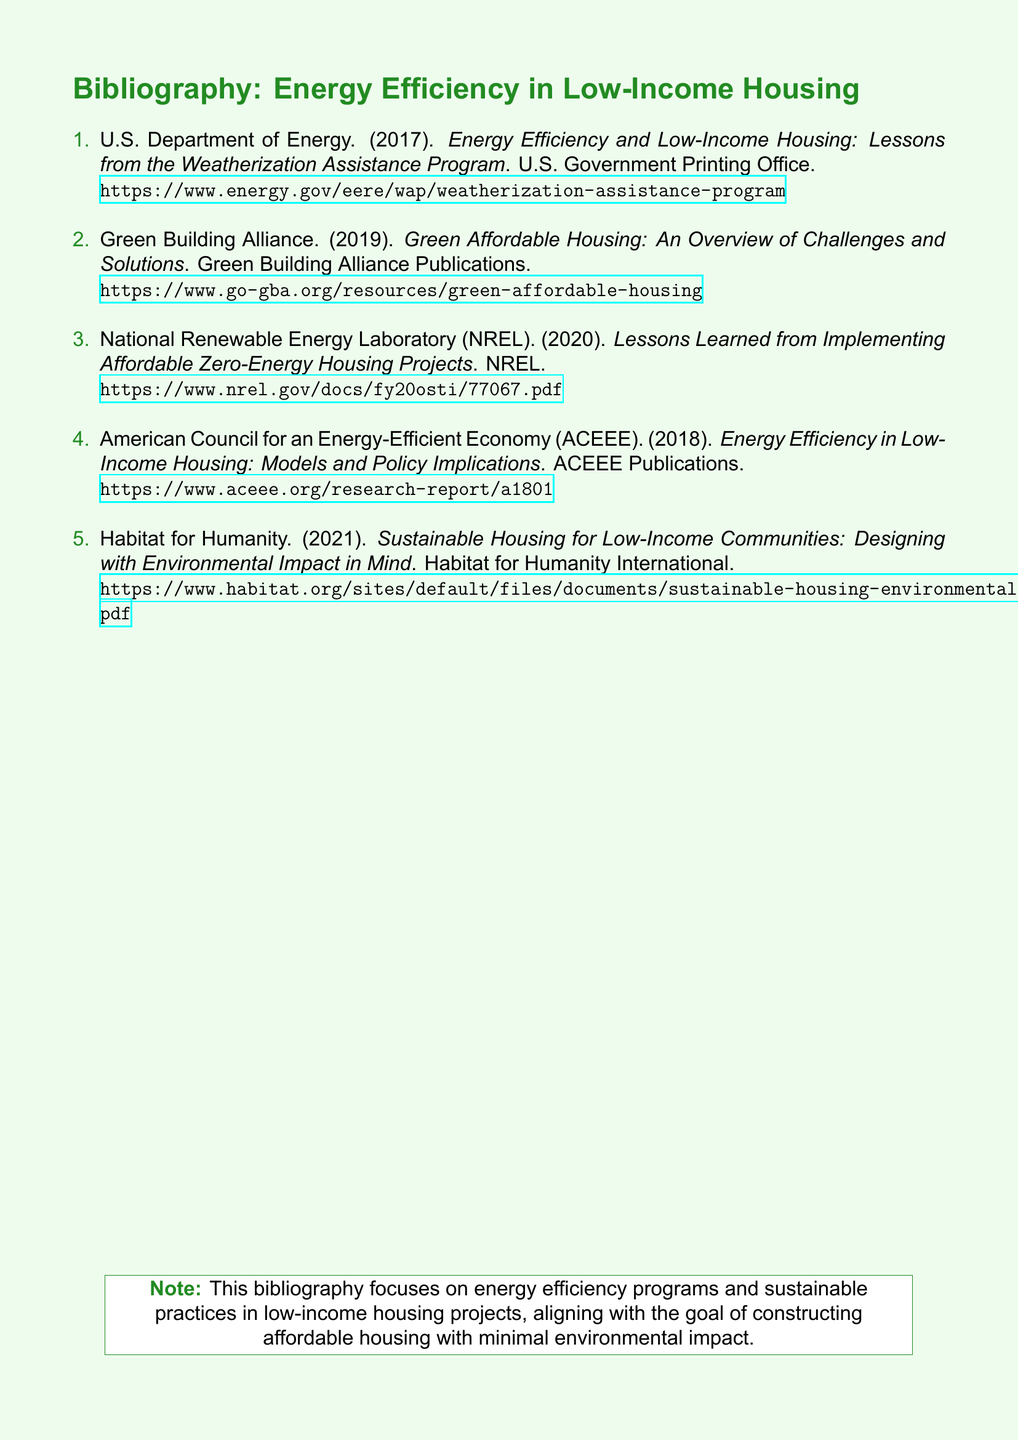What organization published the report in 2017? The report from 2017 is published by the U.S. Department of Energy.
Answer: U.S. Department of Energy What is the title of the 2019 publication by the Green Building Alliance? The title of the publication is "Green Affordable Housing: An Overview of Challenges and Solutions."
Answer: Green Affordable Housing: An Overview of Challenges and Solutions Which laboratory reported lessons learned in 2020? The report about lessons learned in 2020 was published by the National Renewable Energy Laboratory (NREL).
Answer: National Renewable Energy Laboratory What is the main focus of this bibliography? The main focus of this bibliography is energy efficiency programs and sustainable practices in low-income housing projects.
Answer: energy efficiency programs and sustainable practices in low-income housing projects How many documents are listed in the bibliography? There are a total of five documents listed in the bibliography.
Answer: five documents 